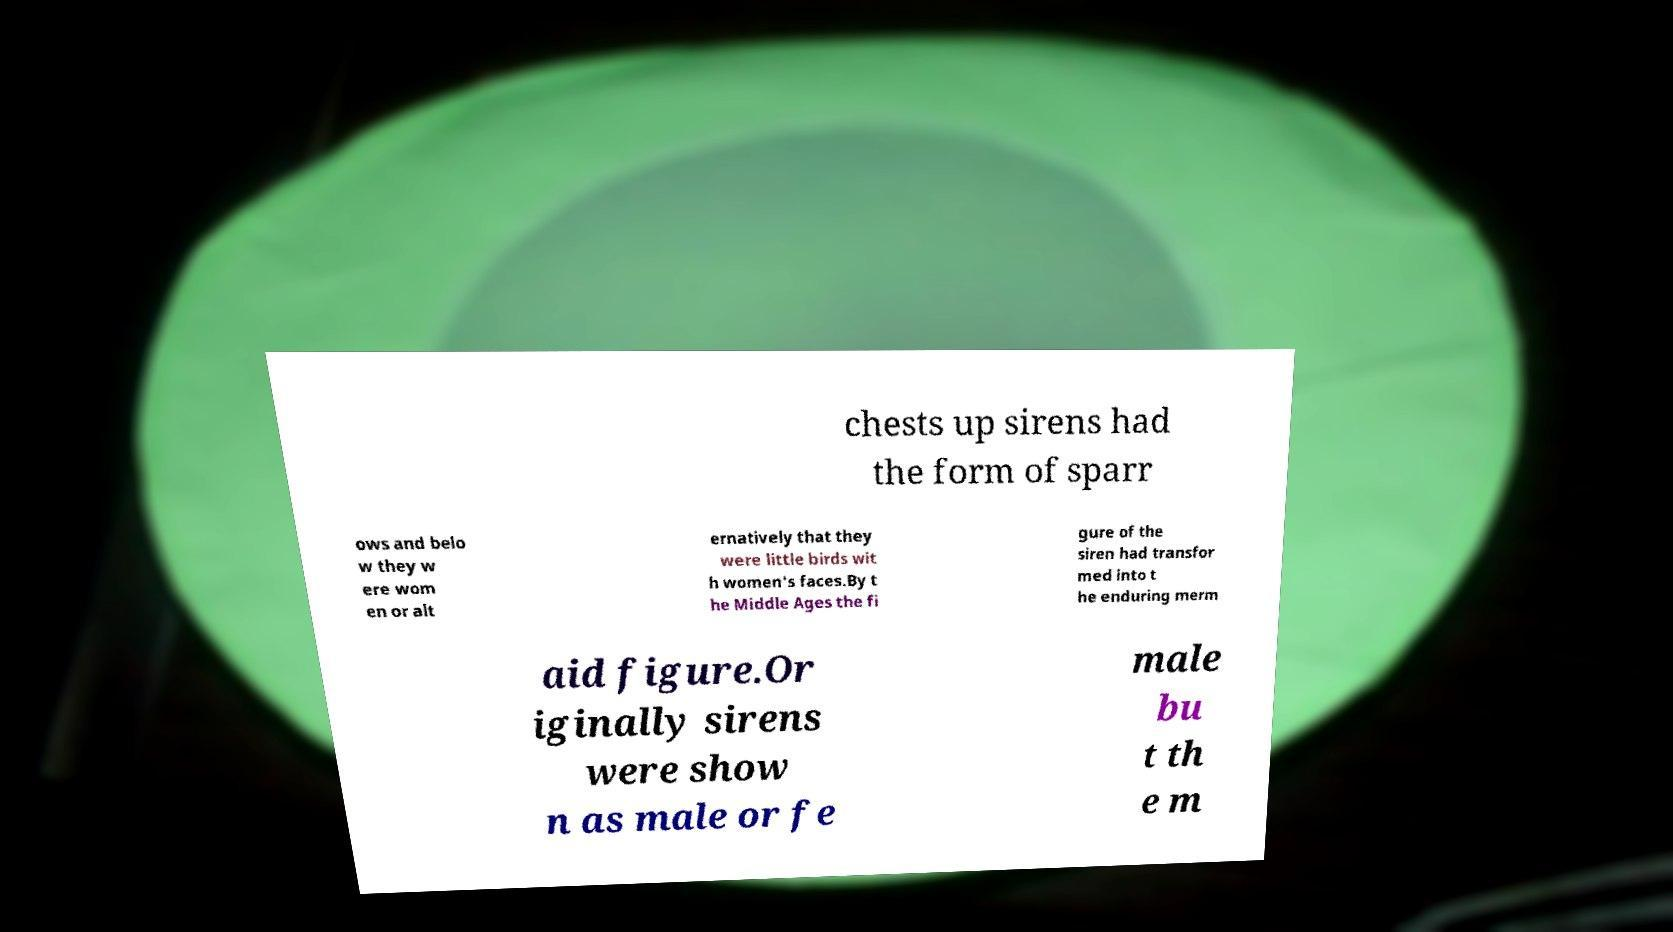Could you extract and type out the text from this image? chests up sirens had the form of sparr ows and belo w they w ere wom en or alt ernatively that they were little birds wit h women's faces.By t he Middle Ages the fi gure of the siren had transfor med into t he enduring merm aid figure.Or iginally sirens were show n as male or fe male bu t th e m 